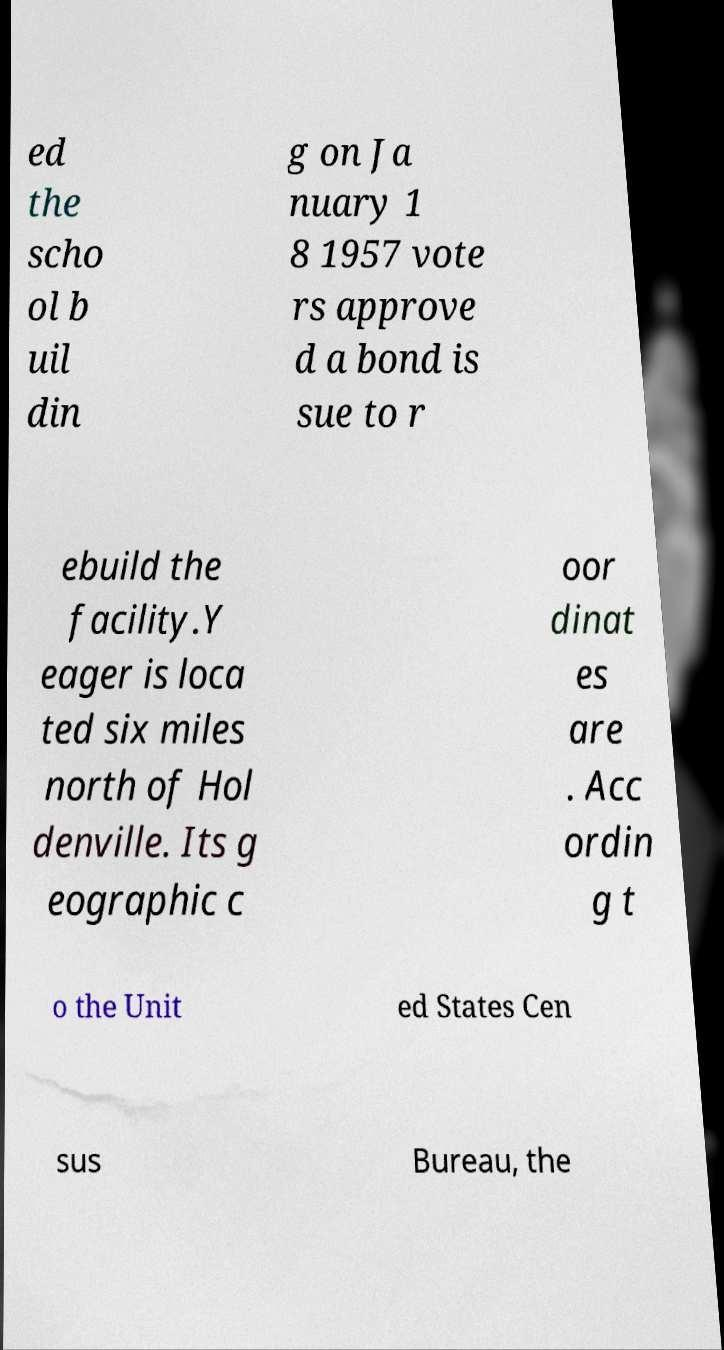There's text embedded in this image that I need extracted. Can you transcribe it verbatim? ed the scho ol b uil din g on Ja nuary 1 8 1957 vote rs approve d a bond is sue to r ebuild the facility.Y eager is loca ted six miles north of Hol denville. Its g eographic c oor dinat es are . Acc ordin g t o the Unit ed States Cen sus Bureau, the 